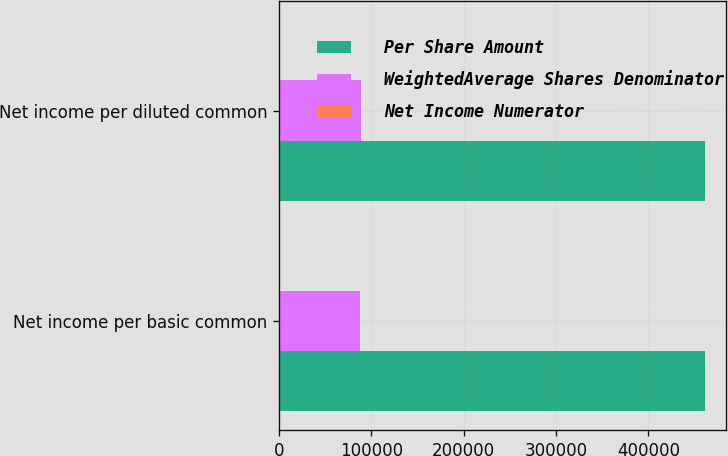Convert chart. <chart><loc_0><loc_0><loc_500><loc_500><stacked_bar_chart><ecel><fcel>Net income per basic common<fcel>Net income per diluted common<nl><fcel>Per Share Amount<fcel>461443<fcel>461443<nl><fcel>WeightedAverage Shares Denominator<fcel>87841<fcel>88979<nl><fcel>Net Income Numerator<fcel>5.25<fcel>5.19<nl></chart> 